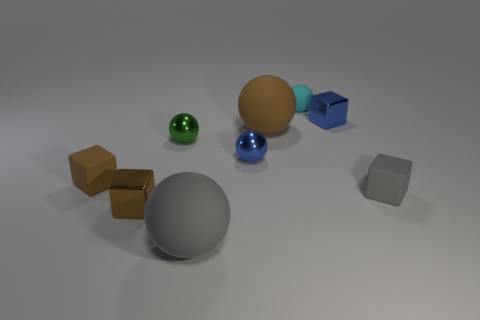The tiny sphere that is the same material as the large brown ball is what color?
Your response must be concise. Cyan. There is a big matte object that is behind the large gray thing; is it the same color as the metal block that is left of the big gray thing?
Provide a short and direct response. Yes. How many blocks are either small brown metal things or tiny green objects?
Give a very brief answer. 1. Are there the same number of brown matte balls behind the blue cube and green cylinders?
Ensure brevity in your answer.  Yes. What is the tiny ball to the left of the small blue metal object that is in front of the blue object on the right side of the cyan rubber object made of?
Keep it short and to the point. Metal. What number of objects are either tiny spheres on the right side of the green metal thing or brown blocks?
Your answer should be compact. 4. How many objects are either large rubber spheres or tiny cyan things behind the gray rubber cube?
Offer a very short reply. 3. What number of tiny metallic cubes are left of the blue shiny thing that is to the right of the brown rubber object that is behind the brown matte block?
Provide a short and direct response. 1. What is the material of the green ball that is the same size as the brown metallic block?
Make the answer very short. Metal. Are there any matte things of the same size as the brown matte sphere?
Offer a very short reply. Yes. 